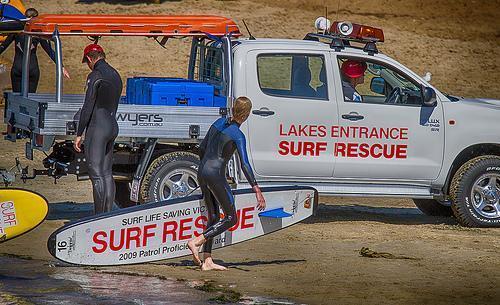How many trucks are there?
Give a very brief answer. 1. 